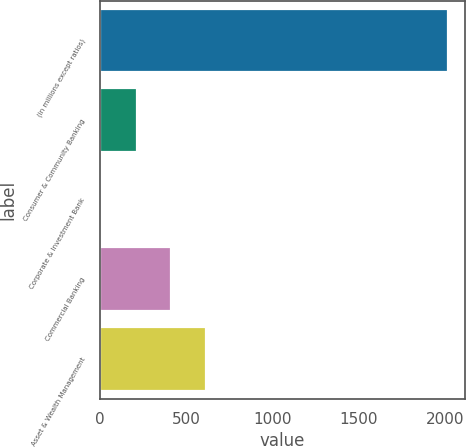Convert chart. <chart><loc_0><loc_0><loc_500><loc_500><bar_chart><fcel>(in millions except ratios)<fcel>Consumer & Community Banking<fcel>Corporate & Investment Bank<fcel>Commercial Banking<fcel>Asset & Wealth Management<nl><fcel>2017<fcel>214.3<fcel>14<fcel>414.6<fcel>614.9<nl></chart> 